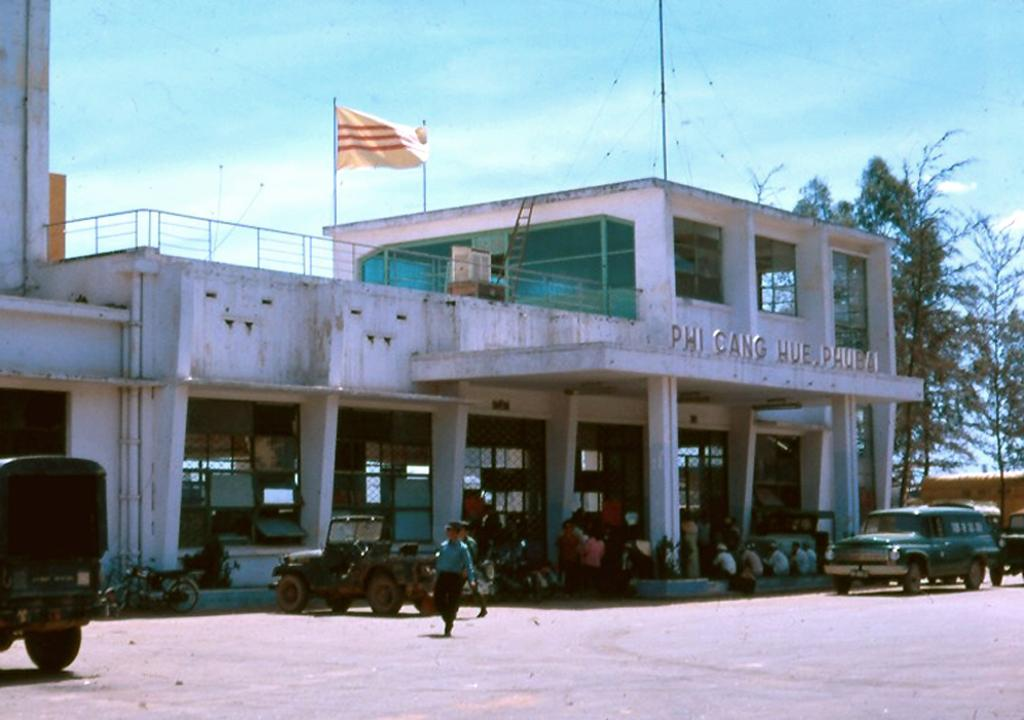What types of vehicles are on the ground in the image? There are vehicles on the ground in the image, but the specific types cannot be determined from the provided facts. What structure can be seen in the image? There is a building in the image. Who or what else is present in the image? There are people in the image. What other natural elements can be seen in the image? There are trees in the image. What is the purpose of the flagpole in the image? The purpose of the flagpole in the image is to hold a flag, but the image does not show a flag. Can you describe any other objects in the image? There are some objects in the image, but their specific nature cannot be determined from the provided facts. What can be seen in the background of the image? The sky is visible in the background of the image. What is the tendency of the eyes of the people in the image? There is no mention of eyes in the provided facts, so it is impossible to determine the tendency of the eyes of the people in the image. At what angle are the vehicles positioned in the image? The angle at which the vehicles are positioned in the image cannot be determined from the provided facts. 